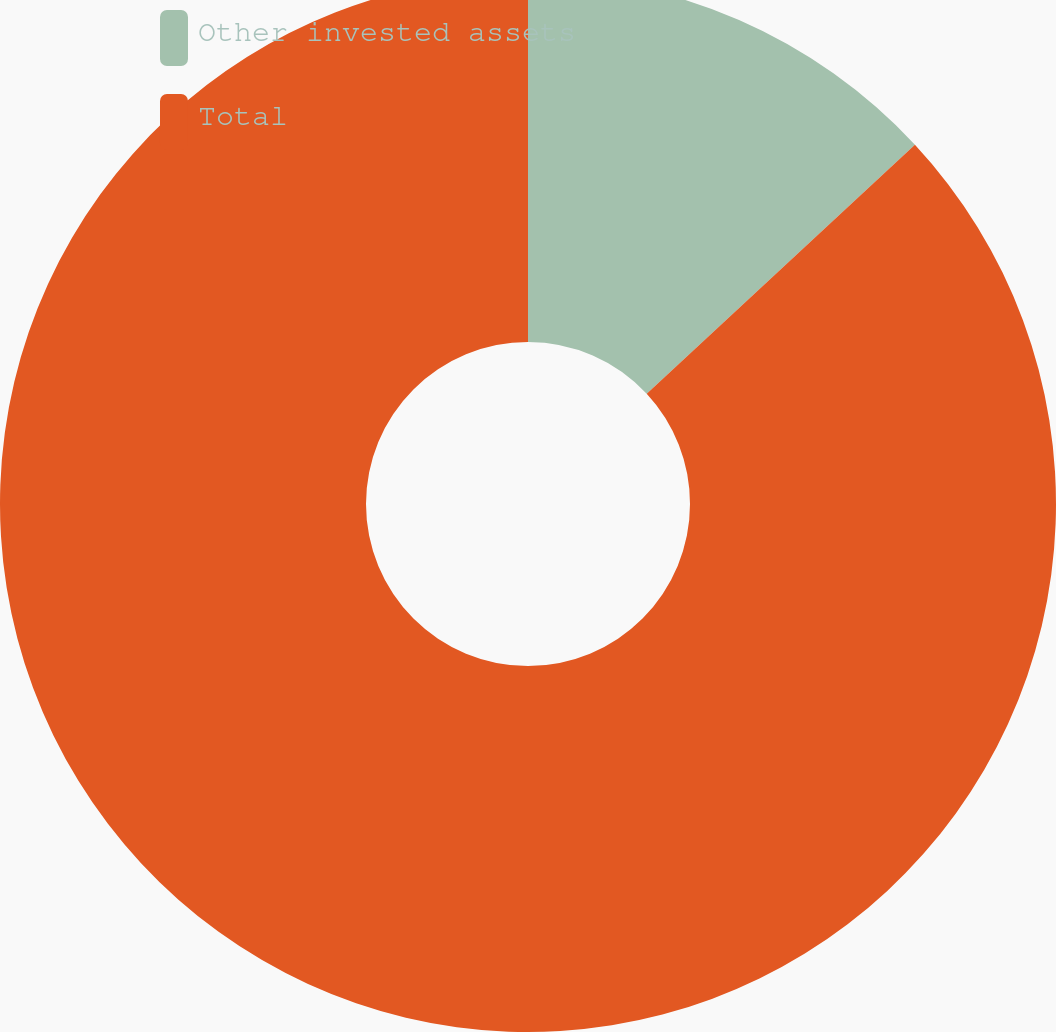<chart> <loc_0><loc_0><loc_500><loc_500><pie_chart><fcel>Other invested assets<fcel>Total<nl><fcel>13.09%<fcel>86.91%<nl></chart> 